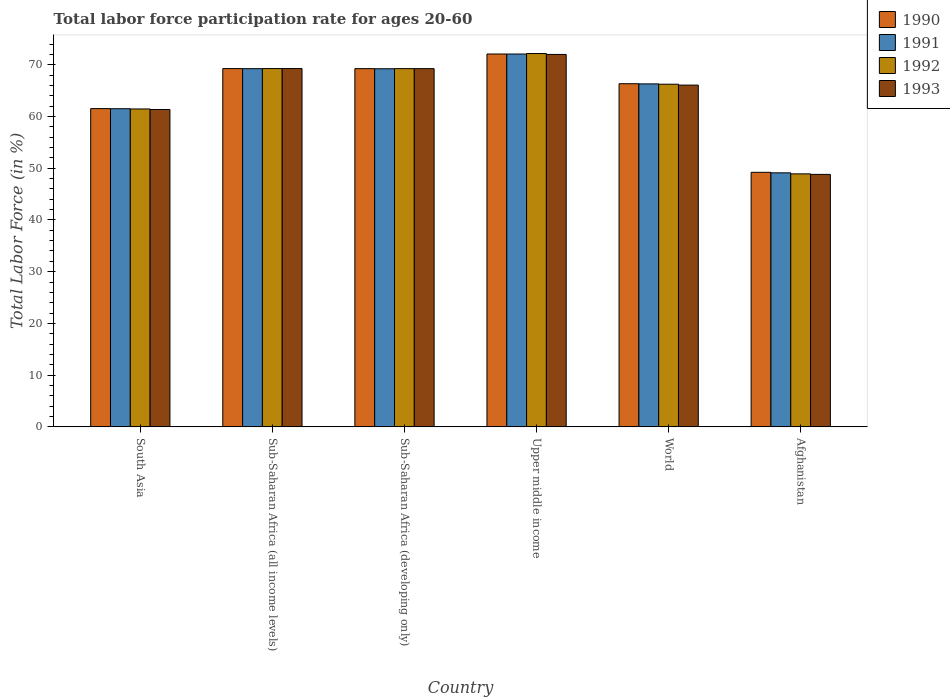Are the number of bars on each tick of the X-axis equal?
Provide a short and direct response. Yes. How many bars are there on the 5th tick from the left?
Provide a succinct answer. 4. How many bars are there on the 4th tick from the right?
Your answer should be compact. 4. What is the label of the 2nd group of bars from the left?
Ensure brevity in your answer.  Sub-Saharan Africa (all income levels). In how many cases, is the number of bars for a given country not equal to the number of legend labels?
Ensure brevity in your answer.  0. What is the labor force participation rate in 1993 in World?
Provide a succinct answer. 66.06. Across all countries, what is the maximum labor force participation rate in 1990?
Your answer should be very brief. 72.07. Across all countries, what is the minimum labor force participation rate in 1991?
Your answer should be compact. 49.1. In which country was the labor force participation rate in 1990 maximum?
Keep it short and to the point. Upper middle income. In which country was the labor force participation rate in 1992 minimum?
Offer a terse response. Afghanistan. What is the total labor force participation rate in 1990 in the graph?
Provide a succinct answer. 387.59. What is the difference between the labor force participation rate in 1990 in Afghanistan and that in Upper middle income?
Offer a very short reply. -22.87. What is the difference between the labor force participation rate in 1992 in Sub-Saharan Africa (all income levels) and the labor force participation rate in 1990 in Sub-Saharan Africa (developing only)?
Offer a very short reply. 0.02. What is the average labor force participation rate in 1993 per country?
Your answer should be very brief. 64.45. What is the difference between the labor force participation rate of/in 1990 and labor force participation rate of/in 1993 in World?
Ensure brevity in your answer.  0.27. What is the ratio of the labor force participation rate in 1992 in Sub-Saharan Africa (all income levels) to that in World?
Make the answer very short. 1.05. Is the labor force participation rate in 1992 in Afghanistan less than that in South Asia?
Your answer should be very brief. Yes. What is the difference between the highest and the second highest labor force participation rate in 1993?
Ensure brevity in your answer.  -0.01. What is the difference between the highest and the lowest labor force participation rate in 1990?
Your answer should be compact. 22.87. In how many countries, is the labor force participation rate in 1992 greater than the average labor force participation rate in 1992 taken over all countries?
Give a very brief answer. 4. Is the sum of the labor force participation rate in 1990 in Afghanistan and World greater than the maximum labor force participation rate in 1992 across all countries?
Your answer should be compact. Yes. Is it the case that in every country, the sum of the labor force participation rate in 1993 and labor force participation rate in 1992 is greater than the sum of labor force participation rate in 1990 and labor force participation rate in 1991?
Your answer should be compact. No. What does the 3rd bar from the left in Afghanistan represents?
Ensure brevity in your answer.  1992. Is it the case that in every country, the sum of the labor force participation rate in 1990 and labor force participation rate in 1993 is greater than the labor force participation rate in 1991?
Your response must be concise. Yes. How many bars are there?
Provide a succinct answer. 24. Are all the bars in the graph horizontal?
Give a very brief answer. No. What is the difference between two consecutive major ticks on the Y-axis?
Make the answer very short. 10. Are the values on the major ticks of Y-axis written in scientific E-notation?
Provide a short and direct response. No. How many legend labels are there?
Give a very brief answer. 4. What is the title of the graph?
Provide a short and direct response. Total labor force participation rate for ages 20-60. Does "1978" appear as one of the legend labels in the graph?
Provide a short and direct response. No. What is the label or title of the Y-axis?
Your answer should be very brief. Total Labor Force (in %). What is the Total Labor Force (in %) in 1990 in South Asia?
Provide a short and direct response. 61.52. What is the Total Labor Force (in %) in 1991 in South Asia?
Offer a terse response. 61.49. What is the Total Labor Force (in %) of 1992 in South Asia?
Your answer should be very brief. 61.44. What is the Total Labor Force (in %) of 1993 in South Asia?
Offer a very short reply. 61.34. What is the Total Labor Force (in %) of 1990 in Sub-Saharan Africa (all income levels)?
Provide a succinct answer. 69.25. What is the Total Labor Force (in %) in 1991 in Sub-Saharan Africa (all income levels)?
Offer a very short reply. 69.23. What is the Total Labor Force (in %) of 1992 in Sub-Saharan Africa (all income levels)?
Offer a terse response. 69.25. What is the Total Labor Force (in %) in 1993 in Sub-Saharan Africa (all income levels)?
Provide a short and direct response. 69.25. What is the Total Labor Force (in %) of 1990 in Sub-Saharan Africa (developing only)?
Offer a terse response. 69.24. What is the Total Labor Force (in %) of 1991 in Sub-Saharan Africa (developing only)?
Give a very brief answer. 69.22. What is the Total Labor Force (in %) of 1992 in Sub-Saharan Africa (developing only)?
Your answer should be very brief. 69.24. What is the Total Labor Force (in %) of 1993 in Sub-Saharan Africa (developing only)?
Your answer should be very brief. 69.24. What is the Total Labor Force (in %) of 1990 in Upper middle income?
Offer a terse response. 72.07. What is the Total Labor Force (in %) in 1991 in Upper middle income?
Your answer should be very brief. 72.06. What is the Total Labor Force (in %) in 1992 in Upper middle income?
Your answer should be very brief. 72.16. What is the Total Labor Force (in %) of 1993 in Upper middle income?
Your answer should be compact. 71.98. What is the Total Labor Force (in %) in 1990 in World?
Give a very brief answer. 66.32. What is the Total Labor Force (in %) in 1991 in World?
Ensure brevity in your answer.  66.29. What is the Total Labor Force (in %) of 1992 in World?
Provide a succinct answer. 66.23. What is the Total Labor Force (in %) in 1993 in World?
Provide a succinct answer. 66.06. What is the Total Labor Force (in %) in 1990 in Afghanistan?
Ensure brevity in your answer.  49.2. What is the Total Labor Force (in %) in 1991 in Afghanistan?
Offer a terse response. 49.1. What is the Total Labor Force (in %) of 1992 in Afghanistan?
Ensure brevity in your answer.  48.9. What is the Total Labor Force (in %) of 1993 in Afghanistan?
Provide a short and direct response. 48.8. Across all countries, what is the maximum Total Labor Force (in %) in 1990?
Keep it short and to the point. 72.07. Across all countries, what is the maximum Total Labor Force (in %) of 1991?
Provide a short and direct response. 72.06. Across all countries, what is the maximum Total Labor Force (in %) of 1992?
Provide a short and direct response. 72.16. Across all countries, what is the maximum Total Labor Force (in %) of 1993?
Offer a very short reply. 71.98. Across all countries, what is the minimum Total Labor Force (in %) of 1990?
Your answer should be compact. 49.2. Across all countries, what is the minimum Total Labor Force (in %) of 1991?
Provide a succinct answer. 49.1. Across all countries, what is the minimum Total Labor Force (in %) of 1992?
Make the answer very short. 48.9. Across all countries, what is the minimum Total Labor Force (in %) of 1993?
Your answer should be very brief. 48.8. What is the total Total Labor Force (in %) in 1990 in the graph?
Offer a very short reply. 387.59. What is the total Total Labor Force (in %) of 1991 in the graph?
Keep it short and to the point. 387.39. What is the total Total Labor Force (in %) in 1992 in the graph?
Offer a very short reply. 387.22. What is the total Total Labor Force (in %) of 1993 in the graph?
Your answer should be compact. 386.67. What is the difference between the Total Labor Force (in %) in 1990 in South Asia and that in Sub-Saharan Africa (all income levels)?
Give a very brief answer. -7.73. What is the difference between the Total Labor Force (in %) of 1991 in South Asia and that in Sub-Saharan Africa (all income levels)?
Your response must be concise. -7.74. What is the difference between the Total Labor Force (in %) of 1992 in South Asia and that in Sub-Saharan Africa (all income levels)?
Keep it short and to the point. -7.81. What is the difference between the Total Labor Force (in %) of 1993 in South Asia and that in Sub-Saharan Africa (all income levels)?
Provide a short and direct response. -7.91. What is the difference between the Total Labor Force (in %) in 1990 in South Asia and that in Sub-Saharan Africa (developing only)?
Ensure brevity in your answer.  -7.72. What is the difference between the Total Labor Force (in %) of 1991 in South Asia and that in Sub-Saharan Africa (developing only)?
Offer a terse response. -7.72. What is the difference between the Total Labor Force (in %) of 1992 in South Asia and that in Sub-Saharan Africa (developing only)?
Your answer should be very brief. -7.79. What is the difference between the Total Labor Force (in %) in 1993 in South Asia and that in Sub-Saharan Africa (developing only)?
Provide a short and direct response. -7.9. What is the difference between the Total Labor Force (in %) of 1990 in South Asia and that in Upper middle income?
Provide a short and direct response. -10.55. What is the difference between the Total Labor Force (in %) in 1991 in South Asia and that in Upper middle income?
Your response must be concise. -10.57. What is the difference between the Total Labor Force (in %) in 1992 in South Asia and that in Upper middle income?
Provide a short and direct response. -10.71. What is the difference between the Total Labor Force (in %) in 1993 in South Asia and that in Upper middle income?
Your response must be concise. -10.64. What is the difference between the Total Labor Force (in %) in 1990 in South Asia and that in World?
Your answer should be compact. -4.81. What is the difference between the Total Labor Force (in %) in 1991 in South Asia and that in World?
Provide a succinct answer. -4.8. What is the difference between the Total Labor Force (in %) of 1992 in South Asia and that in World?
Provide a succinct answer. -4.78. What is the difference between the Total Labor Force (in %) in 1993 in South Asia and that in World?
Provide a succinct answer. -4.71. What is the difference between the Total Labor Force (in %) of 1990 in South Asia and that in Afghanistan?
Offer a terse response. 12.32. What is the difference between the Total Labor Force (in %) in 1991 in South Asia and that in Afghanistan?
Offer a terse response. 12.39. What is the difference between the Total Labor Force (in %) of 1992 in South Asia and that in Afghanistan?
Offer a terse response. 12.54. What is the difference between the Total Labor Force (in %) of 1993 in South Asia and that in Afghanistan?
Provide a succinct answer. 12.54. What is the difference between the Total Labor Force (in %) of 1990 in Sub-Saharan Africa (all income levels) and that in Sub-Saharan Africa (developing only)?
Offer a very short reply. 0.01. What is the difference between the Total Labor Force (in %) of 1991 in Sub-Saharan Africa (all income levels) and that in Sub-Saharan Africa (developing only)?
Offer a very short reply. 0.01. What is the difference between the Total Labor Force (in %) of 1992 in Sub-Saharan Africa (all income levels) and that in Sub-Saharan Africa (developing only)?
Your answer should be compact. 0.01. What is the difference between the Total Labor Force (in %) of 1993 in Sub-Saharan Africa (all income levels) and that in Sub-Saharan Africa (developing only)?
Make the answer very short. 0.01. What is the difference between the Total Labor Force (in %) of 1990 in Sub-Saharan Africa (all income levels) and that in Upper middle income?
Your answer should be compact. -2.82. What is the difference between the Total Labor Force (in %) in 1991 in Sub-Saharan Africa (all income levels) and that in Upper middle income?
Your answer should be very brief. -2.83. What is the difference between the Total Labor Force (in %) in 1992 in Sub-Saharan Africa (all income levels) and that in Upper middle income?
Your response must be concise. -2.9. What is the difference between the Total Labor Force (in %) of 1993 in Sub-Saharan Africa (all income levels) and that in Upper middle income?
Provide a short and direct response. -2.73. What is the difference between the Total Labor Force (in %) of 1990 in Sub-Saharan Africa (all income levels) and that in World?
Your answer should be very brief. 2.93. What is the difference between the Total Labor Force (in %) in 1991 in Sub-Saharan Africa (all income levels) and that in World?
Offer a terse response. 2.94. What is the difference between the Total Labor Force (in %) of 1992 in Sub-Saharan Africa (all income levels) and that in World?
Provide a short and direct response. 3.02. What is the difference between the Total Labor Force (in %) in 1993 in Sub-Saharan Africa (all income levels) and that in World?
Keep it short and to the point. 3.2. What is the difference between the Total Labor Force (in %) of 1990 in Sub-Saharan Africa (all income levels) and that in Afghanistan?
Your response must be concise. 20.05. What is the difference between the Total Labor Force (in %) of 1991 in Sub-Saharan Africa (all income levels) and that in Afghanistan?
Give a very brief answer. 20.13. What is the difference between the Total Labor Force (in %) in 1992 in Sub-Saharan Africa (all income levels) and that in Afghanistan?
Make the answer very short. 20.35. What is the difference between the Total Labor Force (in %) in 1993 in Sub-Saharan Africa (all income levels) and that in Afghanistan?
Offer a very short reply. 20.45. What is the difference between the Total Labor Force (in %) of 1990 in Sub-Saharan Africa (developing only) and that in Upper middle income?
Your answer should be very brief. -2.83. What is the difference between the Total Labor Force (in %) of 1991 in Sub-Saharan Africa (developing only) and that in Upper middle income?
Make the answer very short. -2.84. What is the difference between the Total Labor Force (in %) of 1992 in Sub-Saharan Africa (developing only) and that in Upper middle income?
Offer a terse response. -2.92. What is the difference between the Total Labor Force (in %) of 1993 in Sub-Saharan Africa (developing only) and that in Upper middle income?
Provide a succinct answer. -2.75. What is the difference between the Total Labor Force (in %) in 1990 in Sub-Saharan Africa (developing only) and that in World?
Keep it short and to the point. 2.91. What is the difference between the Total Labor Force (in %) of 1991 in Sub-Saharan Africa (developing only) and that in World?
Your response must be concise. 2.93. What is the difference between the Total Labor Force (in %) in 1992 in Sub-Saharan Africa (developing only) and that in World?
Give a very brief answer. 3.01. What is the difference between the Total Labor Force (in %) of 1993 in Sub-Saharan Africa (developing only) and that in World?
Provide a short and direct response. 3.18. What is the difference between the Total Labor Force (in %) in 1990 in Sub-Saharan Africa (developing only) and that in Afghanistan?
Offer a terse response. 20.04. What is the difference between the Total Labor Force (in %) of 1991 in Sub-Saharan Africa (developing only) and that in Afghanistan?
Offer a very short reply. 20.12. What is the difference between the Total Labor Force (in %) of 1992 in Sub-Saharan Africa (developing only) and that in Afghanistan?
Provide a short and direct response. 20.34. What is the difference between the Total Labor Force (in %) of 1993 in Sub-Saharan Africa (developing only) and that in Afghanistan?
Provide a succinct answer. 20.44. What is the difference between the Total Labor Force (in %) of 1990 in Upper middle income and that in World?
Your answer should be compact. 5.74. What is the difference between the Total Labor Force (in %) of 1991 in Upper middle income and that in World?
Your answer should be very brief. 5.77. What is the difference between the Total Labor Force (in %) in 1992 in Upper middle income and that in World?
Your answer should be compact. 5.93. What is the difference between the Total Labor Force (in %) in 1993 in Upper middle income and that in World?
Provide a succinct answer. 5.93. What is the difference between the Total Labor Force (in %) of 1990 in Upper middle income and that in Afghanistan?
Provide a short and direct response. 22.87. What is the difference between the Total Labor Force (in %) in 1991 in Upper middle income and that in Afghanistan?
Provide a short and direct response. 22.96. What is the difference between the Total Labor Force (in %) in 1992 in Upper middle income and that in Afghanistan?
Give a very brief answer. 23.26. What is the difference between the Total Labor Force (in %) of 1993 in Upper middle income and that in Afghanistan?
Ensure brevity in your answer.  23.18. What is the difference between the Total Labor Force (in %) in 1990 in World and that in Afghanistan?
Give a very brief answer. 17.12. What is the difference between the Total Labor Force (in %) in 1991 in World and that in Afghanistan?
Provide a succinct answer. 17.19. What is the difference between the Total Labor Force (in %) in 1992 in World and that in Afghanistan?
Your answer should be very brief. 17.33. What is the difference between the Total Labor Force (in %) of 1993 in World and that in Afghanistan?
Provide a succinct answer. 17.26. What is the difference between the Total Labor Force (in %) in 1990 in South Asia and the Total Labor Force (in %) in 1991 in Sub-Saharan Africa (all income levels)?
Make the answer very short. -7.72. What is the difference between the Total Labor Force (in %) in 1990 in South Asia and the Total Labor Force (in %) in 1992 in Sub-Saharan Africa (all income levels)?
Keep it short and to the point. -7.74. What is the difference between the Total Labor Force (in %) of 1990 in South Asia and the Total Labor Force (in %) of 1993 in Sub-Saharan Africa (all income levels)?
Offer a very short reply. -7.74. What is the difference between the Total Labor Force (in %) in 1991 in South Asia and the Total Labor Force (in %) in 1992 in Sub-Saharan Africa (all income levels)?
Provide a succinct answer. -7.76. What is the difference between the Total Labor Force (in %) in 1991 in South Asia and the Total Labor Force (in %) in 1993 in Sub-Saharan Africa (all income levels)?
Ensure brevity in your answer.  -7.76. What is the difference between the Total Labor Force (in %) of 1992 in South Asia and the Total Labor Force (in %) of 1993 in Sub-Saharan Africa (all income levels)?
Offer a terse response. -7.81. What is the difference between the Total Labor Force (in %) of 1990 in South Asia and the Total Labor Force (in %) of 1991 in Sub-Saharan Africa (developing only)?
Offer a terse response. -7.7. What is the difference between the Total Labor Force (in %) of 1990 in South Asia and the Total Labor Force (in %) of 1992 in Sub-Saharan Africa (developing only)?
Offer a very short reply. -7.72. What is the difference between the Total Labor Force (in %) in 1990 in South Asia and the Total Labor Force (in %) in 1993 in Sub-Saharan Africa (developing only)?
Ensure brevity in your answer.  -7.72. What is the difference between the Total Labor Force (in %) in 1991 in South Asia and the Total Labor Force (in %) in 1992 in Sub-Saharan Africa (developing only)?
Your response must be concise. -7.75. What is the difference between the Total Labor Force (in %) in 1991 in South Asia and the Total Labor Force (in %) in 1993 in Sub-Saharan Africa (developing only)?
Your answer should be compact. -7.74. What is the difference between the Total Labor Force (in %) in 1992 in South Asia and the Total Labor Force (in %) in 1993 in Sub-Saharan Africa (developing only)?
Your response must be concise. -7.79. What is the difference between the Total Labor Force (in %) of 1990 in South Asia and the Total Labor Force (in %) of 1991 in Upper middle income?
Give a very brief answer. -10.54. What is the difference between the Total Labor Force (in %) of 1990 in South Asia and the Total Labor Force (in %) of 1992 in Upper middle income?
Provide a succinct answer. -10.64. What is the difference between the Total Labor Force (in %) in 1990 in South Asia and the Total Labor Force (in %) in 1993 in Upper middle income?
Offer a very short reply. -10.47. What is the difference between the Total Labor Force (in %) of 1991 in South Asia and the Total Labor Force (in %) of 1992 in Upper middle income?
Provide a short and direct response. -10.66. What is the difference between the Total Labor Force (in %) of 1991 in South Asia and the Total Labor Force (in %) of 1993 in Upper middle income?
Make the answer very short. -10.49. What is the difference between the Total Labor Force (in %) in 1992 in South Asia and the Total Labor Force (in %) in 1993 in Upper middle income?
Make the answer very short. -10.54. What is the difference between the Total Labor Force (in %) of 1990 in South Asia and the Total Labor Force (in %) of 1991 in World?
Offer a very short reply. -4.77. What is the difference between the Total Labor Force (in %) in 1990 in South Asia and the Total Labor Force (in %) in 1992 in World?
Your answer should be very brief. -4.71. What is the difference between the Total Labor Force (in %) in 1990 in South Asia and the Total Labor Force (in %) in 1993 in World?
Ensure brevity in your answer.  -4.54. What is the difference between the Total Labor Force (in %) of 1991 in South Asia and the Total Labor Force (in %) of 1992 in World?
Your response must be concise. -4.73. What is the difference between the Total Labor Force (in %) in 1991 in South Asia and the Total Labor Force (in %) in 1993 in World?
Your response must be concise. -4.56. What is the difference between the Total Labor Force (in %) of 1992 in South Asia and the Total Labor Force (in %) of 1993 in World?
Keep it short and to the point. -4.61. What is the difference between the Total Labor Force (in %) of 1990 in South Asia and the Total Labor Force (in %) of 1991 in Afghanistan?
Offer a very short reply. 12.42. What is the difference between the Total Labor Force (in %) in 1990 in South Asia and the Total Labor Force (in %) in 1992 in Afghanistan?
Provide a short and direct response. 12.62. What is the difference between the Total Labor Force (in %) of 1990 in South Asia and the Total Labor Force (in %) of 1993 in Afghanistan?
Offer a terse response. 12.72. What is the difference between the Total Labor Force (in %) of 1991 in South Asia and the Total Labor Force (in %) of 1992 in Afghanistan?
Ensure brevity in your answer.  12.59. What is the difference between the Total Labor Force (in %) of 1991 in South Asia and the Total Labor Force (in %) of 1993 in Afghanistan?
Offer a terse response. 12.69. What is the difference between the Total Labor Force (in %) in 1992 in South Asia and the Total Labor Force (in %) in 1993 in Afghanistan?
Give a very brief answer. 12.64. What is the difference between the Total Labor Force (in %) of 1990 in Sub-Saharan Africa (all income levels) and the Total Labor Force (in %) of 1991 in Sub-Saharan Africa (developing only)?
Keep it short and to the point. 0.03. What is the difference between the Total Labor Force (in %) in 1990 in Sub-Saharan Africa (all income levels) and the Total Labor Force (in %) in 1992 in Sub-Saharan Africa (developing only)?
Ensure brevity in your answer.  0.01. What is the difference between the Total Labor Force (in %) in 1990 in Sub-Saharan Africa (all income levels) and the Total Labor Force (in %) in 1993 in Sub-Saharan Africa (developing only)?
Give a very brief answer. 0.01. What is the difference between the Total Labor Force (in %) of 1991 in Sub-Saharan Africa (all income levels) and the Total Labor Force (in %) of 1992 in Sub-Saharan Africa (developing only)?
Provide a succinct answer. -0.01. What is the difference between the Total Labor Force (in %) in 1991 in Sub-Saharan Africa (all income levels) and the Total Labor Force (in %) in 1993 in Sub-Saharan Africa (developing only)?
Offer a terse response. -0.01. What is the difference between the Total Labor Force (in %) of 1992 in Sub-Saharan Africa (all income levels) and the Total Labor Force (in %) of 1993 in Sub-Saharan Africa (developing only)?
Provide a succinct answer. 0.02. What is the difference between the Total Labor Force (in %) of 1990 in Sub-Saharan Africa (all income levels) and the Total Labor Force (in %) of 1991 in Upper middle income?
Your response must be concise. -2.81. What is the difference between the Total Labor Force (in %) of 1990 in Sub-Saharan Africa (all income levels) and the Total Labor Force (in %) of 1992 in Upper middle income?
Give a very brief answer. -2.91. What is the difference between the Total Labor Force (in %) in 1990 in Sub-Saharan Africa (all income levels) and the Total Labor Force (in %) in 1993 in Upper middle income?
Your response must be concise. -2.73. What is the difference between the Total Labor Force (in %) in 1991 in Sub-Saharan Africa (all income levels) and the Total Labor Force (in %) in 1992 in Upper middle income?
Your answer should be very brief. -2.93. What is the difference between the Total Labor Force (in %) in 1991 in Sub-Saharan Africa (all income levels) and the Total Labor Force (in %) in 1993 in Upper middle income?
Provide a succinct answer. -2.75. What is the difference between the Total Labor Force (in %) of 1992 in Sub-Saharan Africa (all income levels) and the Total Labor Force (in %) of 1993 in Upper middle income?
Keep it short and to the point. -2.73. What is the difference between the Total Labor Force (in %) in 1990 in Sub-Saharan Africa (all income levels) and the Total Labor Force (in %) in 1991 in World?
Your answer should be compact. 2.96. What is the difference between the Total Labor Force (in %) in 1990 in Sub-Saharan Africa (all income levels) and the Total Labor Force (in %) in 1992 in World?
Ensure brevity in your answer.  3.02. What is the difference between the Total Labor Force (in %) in 1990 in Sub-Saharan Africa (all income levels) and the Total Labor Force (in %) in 1993 in World?
Your answer should be very brief. 3.19. What is the difference between the Total Labor Force (in %) of 1991 in Sub-Saharan Africa (all income levels) and the Total Labor Force (in %) of 1992 in World?
Your answer should be very brief. 3. What is the difference between the Total Labor Force (in %) in 1991 in Sub-Saharan Africa (all income levels) and the Total Labor Force (in %) in 1993 in World?
Offer a very short reply. 3.18. What is the difference between the Total Labor Force (in %) in 1992 in Sub-Saharan Africa (all income levels) and the Total Labor Force (in %) in 1993 in World?
Keep it short and to the point. 3.2. What is the difference between the Total Labor Force (in %) of 1990 in Sub-Saharan Africa (all income levels) and the Total Labor Force (in %) of 1991 in Afghanistan?
Your response must be concise. 20.15. What is the difference between the Total Labor Force (in %) in 1990 in Sub-Saharan Africa (all income levels) and the Total Labor Force (in %) in 1992 in Afghanistan?
Keep it short and to the point. 20.35. What is the difference between the Total Labor Force (in %) in 1990 in Sub-Saharan Africa (all income levels) and the Total Labor Force (in %) in 1993 in Afghanistan?
Make the answer very short. 20.45. What is the difference between the Total Labor Force (in %) in 1991 in Sub-Saharan Africa (all income levels) and the Total Labor Force (in %) in 1992 in Afghanistan?
Your answer should be very brief. 20.33. What is the difference between the Total Labor Force (in %) of 1991 in Sub-Saharan Africa (all income levels) and the Total Labor Force (in %) of 1993 in Afghanistan?
Ensure brevity in your answer.  20.43. What is the difference between the Total Labor Force (in %) in 1992 in Sub-Saharan Africa (all income levels) and the Total Labor Force (in %) in 1993 in Afghanistan?
Make the answer very short. 20.45. What is the difference between the Total Labor Force (in %) of 1990 in Sub-Saharan Africa (developing only) and the Total Labor Force (in %) of 1991 in Upper middle income?
Provide a succinct answer. -2.82. What is the difference between the Total Labor Force (in %) of 1990 in Sub-Saharan Africa (developing only) and the Total Labor Force (in %) of 1992 in Upper middle income?
Offer a terse response. -2.92. What is the difference between the Total Labor Force (in %) of 1990 in Sub-Saharan Africa (developing only) and the Total Labor Force (in %) of 1993 in Upper middle income?
Provide a succinct answer. -2.75. What is the difference between the Total Labor Force (in %) in 1991 in Sub-Saharan Africa (developing only) and the Total Labor Force (in %) in 1992 in Upper middle income?
Give a very brief answer. -2.94. What is the difference between the Total Labor Force (in %) in 1991 in Sub-Saharan Africa (developing only) and the Total Labor Force (in %) in 1993 in Upper middle income?
Your answer should be very brief. -2.77. What is the difference between the Total Labor Force (in %) of 1992 in Sub-Saharan Africa (developing only) and the Total Labor Force (in %) of 1993 in Upper middle income?
Ensure brevity in your answer.  -2.75. What is the difference between the Total Labor Force (in %) in 1990 in Sub-Saharan Africa (developing only) and the Total Labor Force (in %) in 1991 in World?
Offer a terse response. 2.95. What is the difference between the Total Labor Force (in %) of 1990 in Sub-Saharan Africa (developing only) and the Total Labor Force (in %) of 1992 in World?
Make the answer very short. 3.01. What is the difference between the Total Labor Force (in %) of 1990 in Sub-Saharan Africa (developing only) and the Total Labor Force (in %) of 1993 in World?
Ensure brevity in your answer.  3.18. What is the difference between the Total Labor Force (in %) of 1991 in Sub-Saharan Africa (developing only) and the Total Labor Force (in %) of 1992 in World?
Give a very brief answer. 2.99. What is the difference between the Total Labor Force (in %) in 1991 in Sub-Saharan Africa (developing only) and the Total Labor Force (in %) in 1993 in World?
Keep it short and to the point. 3.16. What is the difference between the Total Labor Force (in %) in 1992 in Sub-Saharan Africa (developing only) and the Total Labor Force (in %) in 1993 in World?
Give a very brief answer. 3.18. What is the difference between the Total Labor Force (in %) in 1990 in Sub-Saharan Africa (developing only) and the Total Labor Force (in %) in 1991 in Afghanistan?
Make the answer very short. 20.14. What is the difference between the Total Labor Force (in %) in 1990 in Sub-Saharan Africa (developing only) and the Total Labor Force (in %) in 1992 in Afghanistan?
Keep it short and to the point. 20.34. What is the difference between the Total Labor Force (in %) of 1990 in Sub-Saharan Africa (developing only) and the Total Labor Force (in %) of 1993 in Afghanistan?
Give a very brief answer. 20.44. What is the difference between the Total Labor Force (in %) in 1991 in Sub-Saharan Africa (developing only) and the Total Labor Force (in %) in 1992 in Afghanistan?
Ensure brevity in your answer.  20.32. What is the difference between the Total Labor Force (in %) in 1991 in Sub-Saharan Africa (developing only) and the Total Labor Force (in %) in 1993 in Afghanistan?
Keep it short and to the point. 20.42. What is the difference between the Total Labor Force (in %) in 1992 in Sub-Saharan Africa (developing only) and the Total Labor Force (in %) in 1993 in Afghanistan?
Provide a short and direct response. 20.44. What is the difference between the Total Labor Force (in %) in 1990 in Upper middle income and the Total Labor Force (in %) in 1991 in World?
Your response must be concise. 5.78. What is the difference between the Total Labor Force (in %) in 1990 in Upper middle income and the Total Labor Force (in %) in 1992 in World?
Give a very brief answer. 5.84. What is the difference between the Total Labor Force (in %) of 1990 in Upper middle income and the Total Labor Force (in %) of 1993 in World?
Make the answer very short. 6.01. What is the difference between the Total Labor Force (in %) of 1991 in Upper middle income and the Total Labor Force (in %) of 1992 in World?
Offer a very short reply. 5.83. What is the difference between the Total Labor Force (in %) of 1991 in Upper middle income and the Total Labor Force (in %) of 1993 in World?
Your response must be concise. 6. What is the difference between the Total Labor Force (in %) in 1992 in Upper middle income and the Total Labor Force (in %) in 1993 in World?
Offer a terse response. 6.1. What is the difference between the Total Labor Force (in %) in 1990 in Upper middle income and the Total Labor Force (in %) in 1991 in Afghanistan?
Your response must be concise. 22.97. What is the difference between the Total Labor Force (in %) of 1990 in Upper middle income and the Total Labor Force (in %) of 1992 in Afghanistan?
Provide a succinct answer. 23.17. What is the difference between the Total Labor Force (in %) in 1990 in Upper middle income and the Total Labor Force (in %) in 1993 in Afghanistan?
Offer a terse response. 23.27. What is the difference between the Total Labor Force (in %) in 1991 in Upper middle income and the Total Labor Force (in %) in 1992 in Afghanistan?
Offer a terse response. 23.16. What is the difference between the Total Labor Force (in %) of 1991 in Upper middle income and the Total Labor Force (in %) of 1993 in Afghanistan?
Provide a short and direct response. 23.26. What is the difference between the Total Labor Force (in %) of 1992 in Upper middle income and the Total Labor Force (in %) of 1993 in Afghanistan?
Provide a succinct answer. 23.36. What is the difference between the Total Labor Force (in %) in 1990 in World and the Total Labor Force (in %) in 1991 in Afghanistan?
Give a very brief answer. 17.22. What is the difference between the Total Labor Force (in %) in 1990 in World and the Total Labor Force (in %) in 1992 in Afghanistan?
Keep it short and to the point. 17.42. What is the difference between the Total Labor Force (in %) in 1990 in World and the Total Labor Force (in %) in 1993 in Afghanistan?
Your answer should be compact. 17.52. What is the difference between the Total Labor Force (in %) in 1991 in World and the Total Labor Force (in %) in 1992 in Afghanistan?
Provide a short and direct response. 17.39. What is the difference between the Total Labor Force (in %) in 1991 in World and the Total Labor Force (in %) in 1993 in Afghanistan?
Provide a short and direct response. 17.49. What is the difference between the Total Labor Force (in %) in 1992 in World and the Total Labor Force (in %) in 1993 in Afghanistan?
Your response must be concise. 17.43. What is the average Total Labor Force (in %) of 1990 per country?
Your answer should be very brief. 64.6. What is the average Total Labor Force (in %) of 1991 per country?
Your response must be concise. 64.57. What is the average Total Labor Force (in %) of 1992 per country?
Provide a succinct answer. 64.54. What is the average Total Labor Force (in %) in 1993 per country?
Provide a succinct answer. 64.44. What is the difference between the Total Labor Force (in %) of 1990 and Total Labor Force (in %) of 1991 in South Asia?
Your response must be concise. 0.02. What is the difference between the Total Labor Force (in %) in 1990 and Total Labor Force (in %) in 1992 in South Asia?
Provide a succinct answer. 0.07. What is the difference between the Total Labor Force (in %) in 1990 and Total Labor Force (in %) in 1993 in South Asia?
Your answer should be compact. 0.17. What is the difference between the Total Labor Force (in %) of 1991 and Total Labor Force (in %) of 1992 in South Asia?
Your response must be concise. 0.05. What is the difference between the Total Labor Force (in %) of 1991 and Total Labor Force (in %) of 1993 in South Asia?
Your response must be concise. 0.15. What is the difference between the Total Labor Force (in %) in 1992 and Total Labor Force (in %) in 1993 in South Asia?
Provide a short and direct response. 0.1. What is the difference between the Total Labor Force (in %) in 1990 and Total Labor Force (in %) in 1991 in Sub-Saharan Africa (all income levels)?
Keep it short and to the point. 0.02. What is the difference between the Total Labor Force (in %) of 1990 and Total Labor Force (in %) of 1992 in Sub-Saharan Africa (all income levels)?
Your answer should be compact. -0. What is the difference between the Total Labor Force (in %) in 1990 and Total Labor Force (in %) in 1993 in Sub-Saharan Africa (all income levels)?
Your answer should be compact. -0. What is the difference between the Total Labor Force (in %) of 1991 and Total Labor Force (in %) of 1992 in Sub-Saharan Africa (all income levels)?
Ensure brevity in your answer.  -0.02. What is the difference between the Total Labor Force (in %) of 1991 and Total Labor Force (in %) of 1993 in Sub-Saharan Africa (all income levels)?
Provide a short and direct response. -0.02. What is the difference between the Total Labor Force (in %) in 1992 and Total Labor Force (in %) in 1993 in Sub-Saharan Africa (all income levels)?
Provide a succinct answer. 0. What is the difference between the Total Labor Force (in %) of 1990 and Total Labor Force (in %) of 1991 in Sub-Saharan Africa (developing only)?
Keep it short and to the point. 0.02. What is the difference between the Total Labor Force (in %) in 1990 and Total Labor Force (in %) in 1992 in Sub-Saharan Africa (developing only)?
Keep it short and to the point. -0. What is the difference between the Total Labor Force (in %) in 1990 and Total Labor Force (in %) in 1993 in Sub-Saharan Africa (developing only)?
Make the answer very short. -0. What is the difference between the Total Labor Force (in %) of 1991 and Total Labor Force (in %) of 1992 in Sub-Saharan Africa (developing only)?
Keep it short and to the point. -0.02. What is the difference between the Total Labor Force (in %) of 1991 and Total Labor Force (in %) of 1993 in Sub-Saharan Africa (developing only)?
Give a very brief answer. -0.02. What is the difference between the Total Labor Force (in %) of 1992 and Total Labor Force (in %) of 1993 in Sub-Saharan Africa (developing only)?
Offer a very short reply. 0. What is the difference between the Total Labor Force (in %) in 1990 and Total Labor Force (in %) in 1991 in Upper middle income?
Keep it short and to the point. 0.01. What is the difference between the Total Labor Force (in %) of 1990 and Total Labor Force (in %) of 1992 in Upper middle income?
Offer a terse response. -0.09. What is the difference between the Total Labor Force (in %) of 1990 and Total Labor Force (in %) of 1993 in Upper middle income?
Your answer should be very brief. 0.08. What is the difference between the Total Labor Force (in %) in 1991 and Total Labor Force (in %) in 1992 in Upper middle income?
Your response must be concise. -0.1. What is the difference between the Total Labor Force (in %) in 1991 and Total Labor Force (in %) in 1993 in Upper middle income?
Provide a short and direct response. 0.08. What is the difference between the Total Labor Force (in %) of 1992 and Total Labor Force (in %) of 1993 in Upper middle income?
Make the answer very short. 0.17. What is the difference between the Total Labor Force (in %) of 1990 and Total Labor Force (in %) of 1991 in World?
Give a very brief answer. 0.03. What is the difference between the Total Labor Force (in %) in 1990 and Total Labor Force (in %) in 1992 in World?
Give a very brief answer. 0.09. What is the difference between the Total Labor Force (in %) of 1990 and Total Labor Force (in %) of 1993 in World?
Keep it short and to the point. 0.27. What is the difference between the Total Labor Force (in %) of 1991 and Total Labor Force (in %) of 1992 in World?
Make the answer very short. 0.06. What is the difference between the Total Labor Force (in %) in 1991 and Total Labor Force (in %) in 1993 in World?
Offer a very short reply. 0.23. What is the difference between the Total Labor Force (in %) in 1992 and Total Labor Force (in %) in 1993 in World?
Provide a short and direct response. 0.17. What is the difference between the Total Labor Force (in %) in 1991 and Total Labor Force (in %) in 1992 in Afghanistan?
Provide a succinct answer. 0.2. What is the difference between the Total Labor Force (in %) in 1991 and Total Labor Force (in %) in 1993 in Afghanistan?
Offer a very short reply. 0.3. What is the ratio of the Total Labor Force (in %) of 1990 in South Asia to that in Sub-Saharan Africa (all income levels)?
Your answer should be compact. 0.89. What is the ratio of the Total Labor Force (in %) of 1991 in South Asia to that in Sub-Saharan Africa (all income levels)?
Offer a terse response. 0.89. What is the ratio of the Total Labor Force (in %) in 1992 in South Asia to that in Sub-Saharan Africa (all income levels)?
Give a very brief answer. 0.89. What is the ratio of the Total Labor Force (in %) of 1993 in South Asia to that in Sub-Saharan Africa (all income levels)?
Make the answer very short. 0.89. What is the ratio of the Total Labor Force (in %) of 1990 in South Asia to that in Sub-Saharan Africa (developing only)?
Ensure brevity in your answer.  0.89. What is the ratio of the Total Labor Force (in %) of 1991 in South Asia to that in Sub-Saharan Africa (developing only)?
Ensure brevity in your answer.  0.89. What is the ratio of the Total Labor Force (in %) of 1992 in South Asia to that in Sub-Saharan Africa (developing only)?
Offer a terse response. 0.89. What is the ratio of the Total Labor Force (in %) in 1993 in South Asia to that in Sub-Saharan Africa (developing only)?
Your answer should be compact. 0.89. What is the ratio of the Total Labor Force (in %) in 1990 in South Asia to that in Upper middle income?
Give a very brief answer. 0.85. What is the ratio of the Total Labor Force (in %) in 1991 in South Asia to that in Upper middle income?
Give a very brief answer. 0.85. What is the ratio of the Total Labor Force (in %) in 1992 in South Asia to that in Upper middle income?
Ensure brevity in your answer.  0.85. What is the ratio of the Total Labor Force (in %) in 1993 in South Asia to that in Upper middle income?
Offer a very short reply. 0.85. What is the ratio of the Total Labor Force (in %) in 1990 in South Asia to that in World?
Keep it short and to the point. 0.93. What is the ratio of the Total Labor Force (in %) in 1991 in South Asia to that in World?
Provide a succinct answer. 0.93. What is the ratio of the Total Labor Force (in %) of 1992 in South Asia to that in World?
Your response must be concise. 0.93. What is the ratio of the Total Labor Force (in %) in 1990 in South Asia to that in Afghanistan?
Your answer should be compact. 1.25. What is the ratio of the Total Labor Force (in %) in 1991 in South Asia to that in Afghanistan?
Your response must be concise. 1.25. What is the ratio of the Total Labor Force (in %) of 1992 in South Asia to that in Afghanistan?
Keep it short and to the point. 1.26. What is the ratio of the Total Labor Force (in %) of 1993 in South Asia to that in Afghanistan?
Your answer should be very brief. 1.26. What is the ratio of the Total Labor Force (in %) of 1990 in Sub-Saharan Africa (all income levels) to that in Upper middle income?
Offer a very short reply. 0.96. What is the ratio of the Total Labor Force (in %) in 1991 in Sub-Saharan Africa (all income levels) to that in Upper middle income?
Your answer should be very brief. 0.96. What is the ratio of the Total Labor Force (in %) of 1992 in Sub-Saharan Africa (all income levels) to that in Upper middle income?
Keep it short and to the point. 0.96. What is the ratio of the Total Labor Force (in %) of 1993 in Sub-Saharan Africa (all income levels) to that in Upper middle income?
Provide a short and direct response. 0.96. What is the ratio of the Total Labor Force (in %) in 1990 in Sub-Saharan Africa (all income levels) to that in World?
Provide a short and direct response. 1.04. What is the ratio of the Total Labor Force (in %) of 1991 in Sub-Saharan Africa (all income levels) to that in World?
Offer a very short reply. 1.04. What is the ratio of the Total Labor Force (in %) of 1992 in Sub-Saharan Africa (all income levels) to that in World?
Make the answer very short. 1.05. What is the ratio of the Total Labor Force (in %) in 1993 in Sub-Saharan Africa (all income levels) to that in World?
Offer a terse response. 1.05. What is the ratio of the Total Labor Force (in %) in 1990 in Sub-Saharan Africa (all income levels) to that in Afghanistan?
Ensure brevity in your answer.  1.41. What is the ratio of the Total Labor Force (in %) in 1991 in Sub-Saharan Africa (all income levels) to that in Afghanistan?
Your answer should be very brief. 1.41. What is the ratio of the Total Labor Force (in %) in 1992 in Sub-Saharan Africa (all income levels) to that in Afghanistan?
Your answer should be very brief. 1.42. What is the ratio of the Total Labor Force (in %) of 1993 in Sub-Saharan Africa (all income levels) to that in Afghanistan?
Ensure brevity in your answer.  1.42. What is the ratio of the Total Labor Force (in %) in 1990 in Sub-Saharan Africa (developing only) to that in Upper middle income?
Your answer should be compact. 0.96. What is the ratio of the Total Labor Force (in %) in 1991 in Sub-Saharan Africa (developing only) to that in Upper middle income?
Offer a very short reply. 0.96. What is the ratio of the Total Labor Force (in %) of 1992 in Sub-Saharan Africa (developing only) to that in Upper middle income?
Your response must be concise. 0.96. What is the ratio of the Total Labor Force (in %) of 1993 in Sub-Saharan Africa (developing only) to that in Upper middle income?
Provide a succinct answer. 0.96. What is the ratio of the Total Labor Force (in %) of 1990 in Sub-Saharan Africa (developing only) to that in World?
Your response must be concise. 1.04. What is the ratio of the Total Labor Force (in %) of 1991 in Sub-Saharan Africa (developing only) to that in World?
Provide a succinct answer. 1.04. What is the ratio of the Total Labor Force (in %) of 1992 in Sub-Saharan Africa (developing only) to that in World?
Offer a terse response. 1.05. What is the ratio of the Total Labor Force (in %) of 1993 in Sub-Saharan Africa (developing only) to that in World?
Ensure brevity in your answer.  1.05. What is the ratio of the Total Labor Force (in %) in 1990 in Sub-Saharan Africa (developing only) to that in Afghanistan?
Your answer should be very brief. 1.41. What is the ratio of the Total Labor Force (in %) of 1991 in Sub-Saharan Africa (developing only) to that in Afghanistan?
Your answer should be very brief. 1.41. What is the ratio of the Total Labor Force (in %) of 1992 in Sub-Saharan Africa (developing only) to that in Afghanistan?
Ensure brevity in your answer.  1.42. What is the ratio of the Total Labor Force (in %) in 1993 in Sub-Saharan Africa (developing only) to that in Afghanistan?
Your answer should be very brief. 1.42. What is the ratio of the Total Labor Force (in %) of 1990 in Upper middle income to that in World?
Make the answer very short. 1.09. What is the ratio of the Total Labor Force (in %) of 1991 in Upper middle income to that in World?
Your response must be concise. 1.09. What is the ratio of the Total Labor Force (in %) in 1992 in Upper middle income to that in World?
Make the answer very short. 1.09. What is the ratio of the Total Labor Force (in %) in 1993 in Upper middle income to that in World?
Keep it short and to the point. 1.09. What is the ratio of the Total Labor Force (in %) in 1990 in Upper middle income to that in Afghanistan?
Ensure brevity in your answer.  1.46. What is the ratio of the Total Labor Force (in %) in 1991 in Upper middle income to that in Afghanistan?
Provide a short and direct response. 1.47. What is the ratio of the Total Labor Force (in %) in 1992 in Upper middle income to that in Afghanistan?
Offer a very short reply. 1.48. What is the ratio of the Total Labor Force (in %) in 1993 in Upper middle income to that in Afghanistan?
Give a very brief answer. 1.48. What is the ratio of the Total Labor Force (in %) in 1990 in World to that in Afghanistan?
Provide a short and direct response. 1.35. What is the ratio of the Total Labor Force (in %) in 1991 in World to that in Afghanistan?
Ensure brevity in your answer.  1.35. What is the ratio of the Total Labor Force (in %) of 1992 in World to that in Afghanistan?
Your response must be concise. 1.35. What is the ratio of the Total Labor Force (in %) of 1993 in World to that in Afghanistan?
Your response must be concise. 1.35. What is the difference between the highest and the second highest Total Labor Force (in %) of 1990?
Your response must be concise. 2.82. What is the difference between the highest and the second highest Total Labor Force (in %) of 1991?
Your answer should be very brief. 2.83. What is the difference between the highest and the second highest Total Labor Force (in %) in 1992?
Ensure brevity in your answer.  2.9. What is the difference between the highest and the second highest Total Labor Force (in %) of 1993?
Provide a short and direct response. 2.73. What is the difference between the highest and the lowest Total Labor Force (in %) in 1990?
Provide a short and direct response. 22.87. What is the difference between the highest and the lowest Total Labor Force (in %) in 1991?
Provide a short and direct response. 22.96. What is the difference between the highest and the lowest Total Labor Force (in %) of 1992?
Provide a short and direct response. 23.26. What is the difference between the highest and the lowest Total Labor Force (in %) of 1993?
Provide a short and direct response. 23.18. 